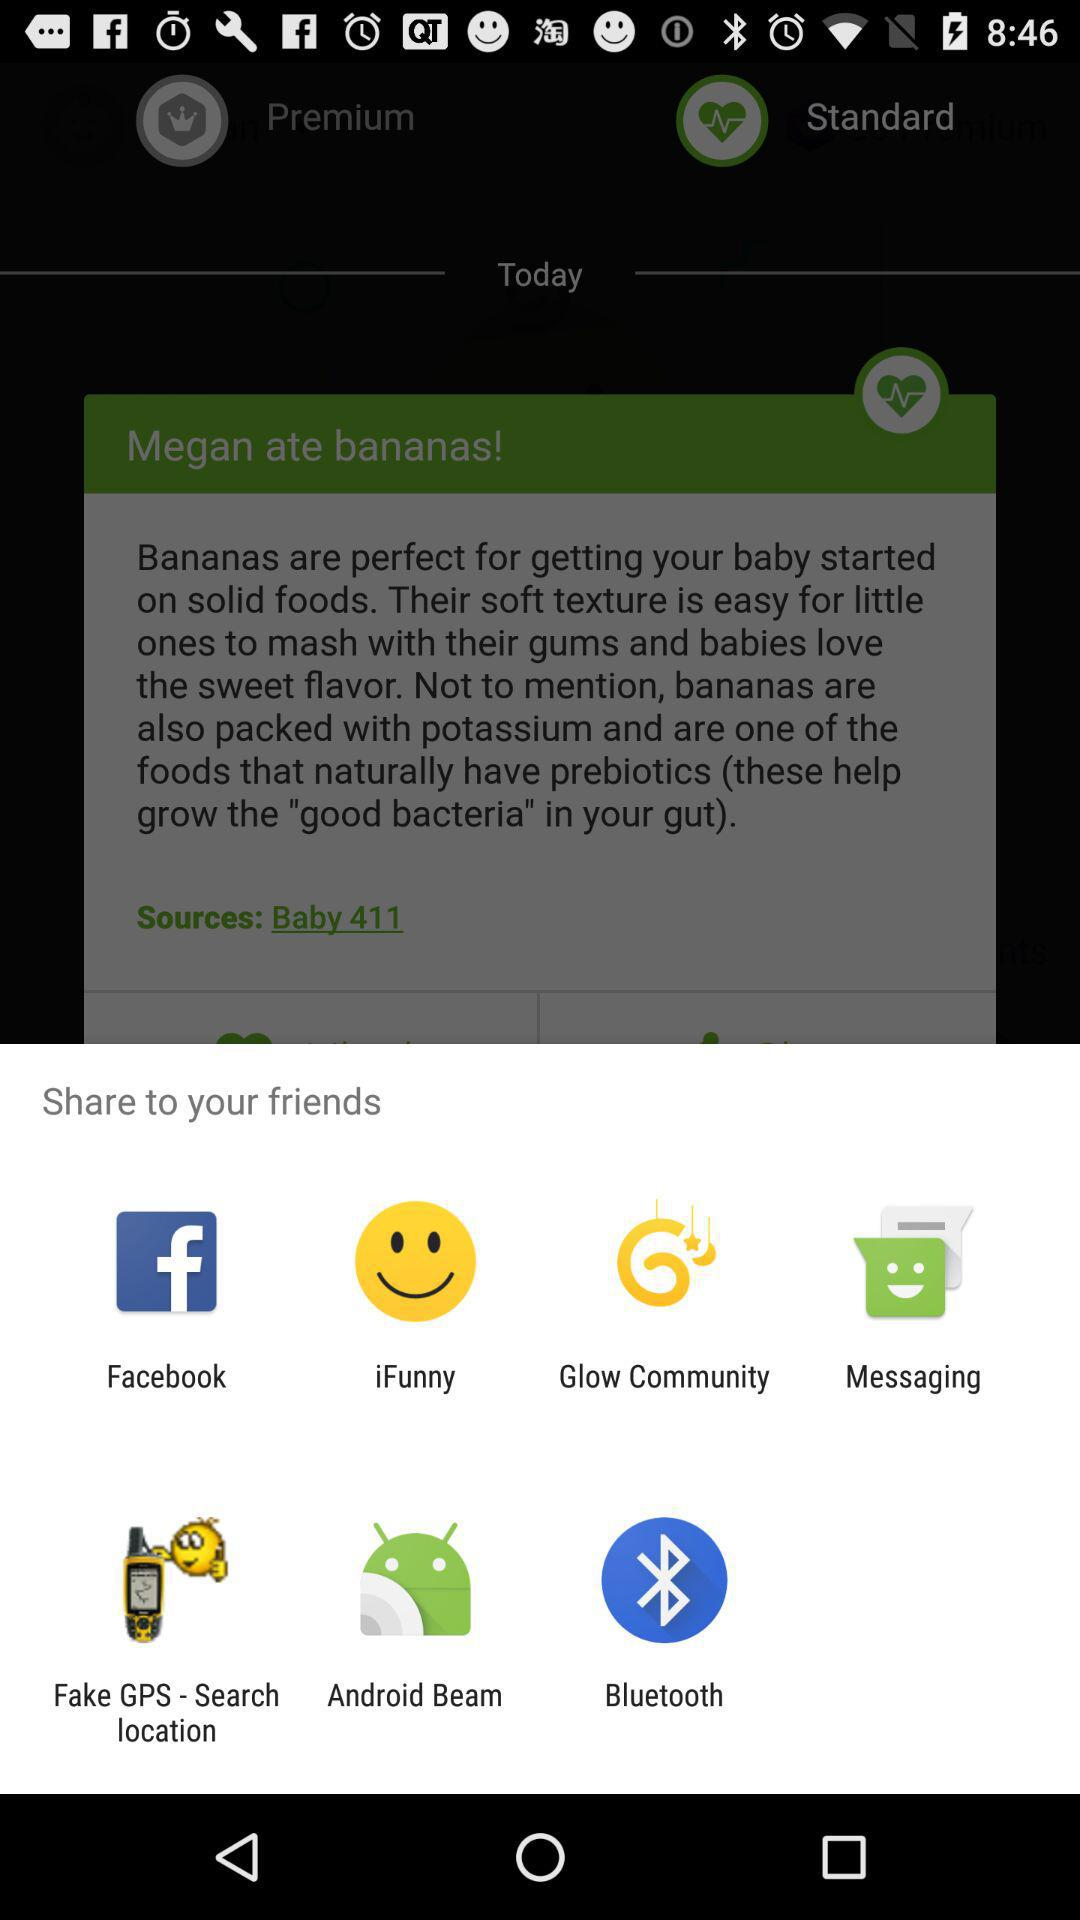What are the different applications through which we can share? You can share through "Facebook", "iFunny", "Glow Community", "Messaging", "Fake GPS - Search location", "Android Beam" and "Bluetooth". 